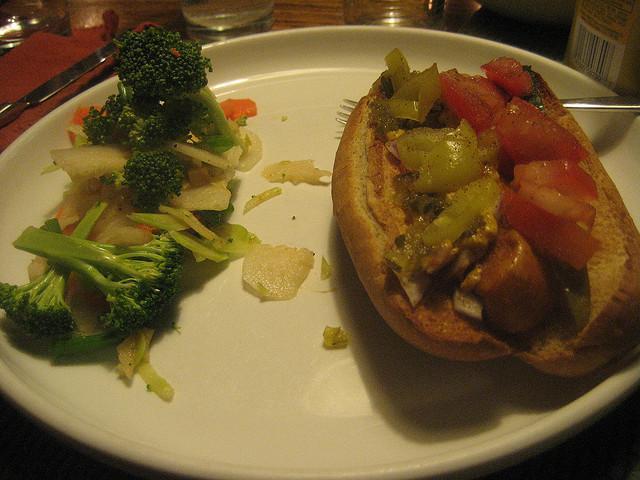What is on the left of the plate?
Indicate the correct response and explain using: 'Answer: answer
Rationale: rationale.'
Options: Eggs, apple, broccoli, pumpkin. Answer: broccoli.
Rationale: Broccoli is shown. 